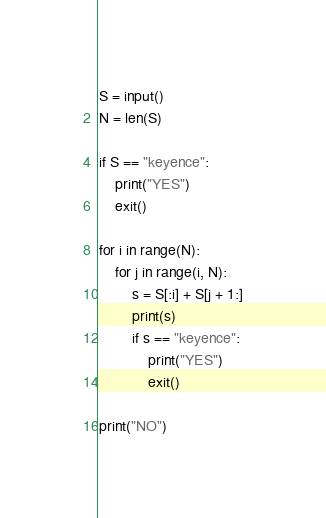Convert code to text. <code><loc_0><loc_0><loc_500><loc_500><_Python_>S = input()
N = len(S)

if S == "keyence":
    print("YES")
    exit()

for i in range(N):
    for j in range(i, N):
        s = S[:i] + S[j + 1:]
        print(s)
        if s == "keyence":
            print("YES")
            exit()

print("NO")
</code> 